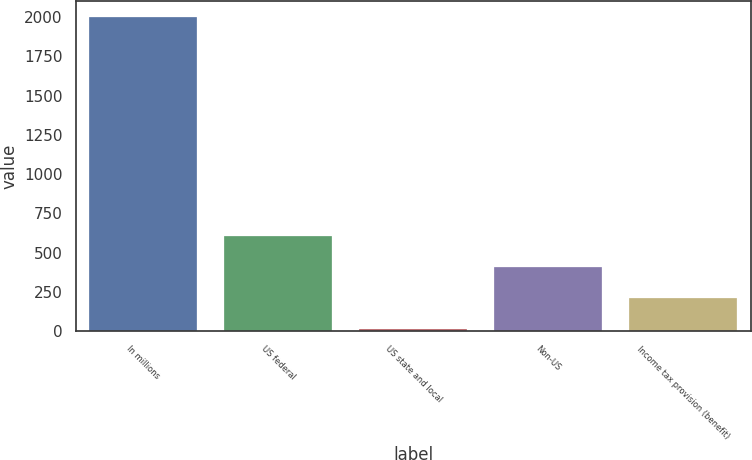<chart> <loc_0><loc_0><loc_500><loc_500><bar_chart><fcel>In millions<fcel>US federal<fcel>US state and local<fcel>Non-US<fcel>Income tax provision (benefit)<nl><fcel>2003<fcel>608.6<fcel>11<fcel>409.4<fcel>210.2<nl></chart> 